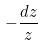<formula> <loc_0><loc_0><loc_500><loc_500>- \frac { d z } { z }</formula> 